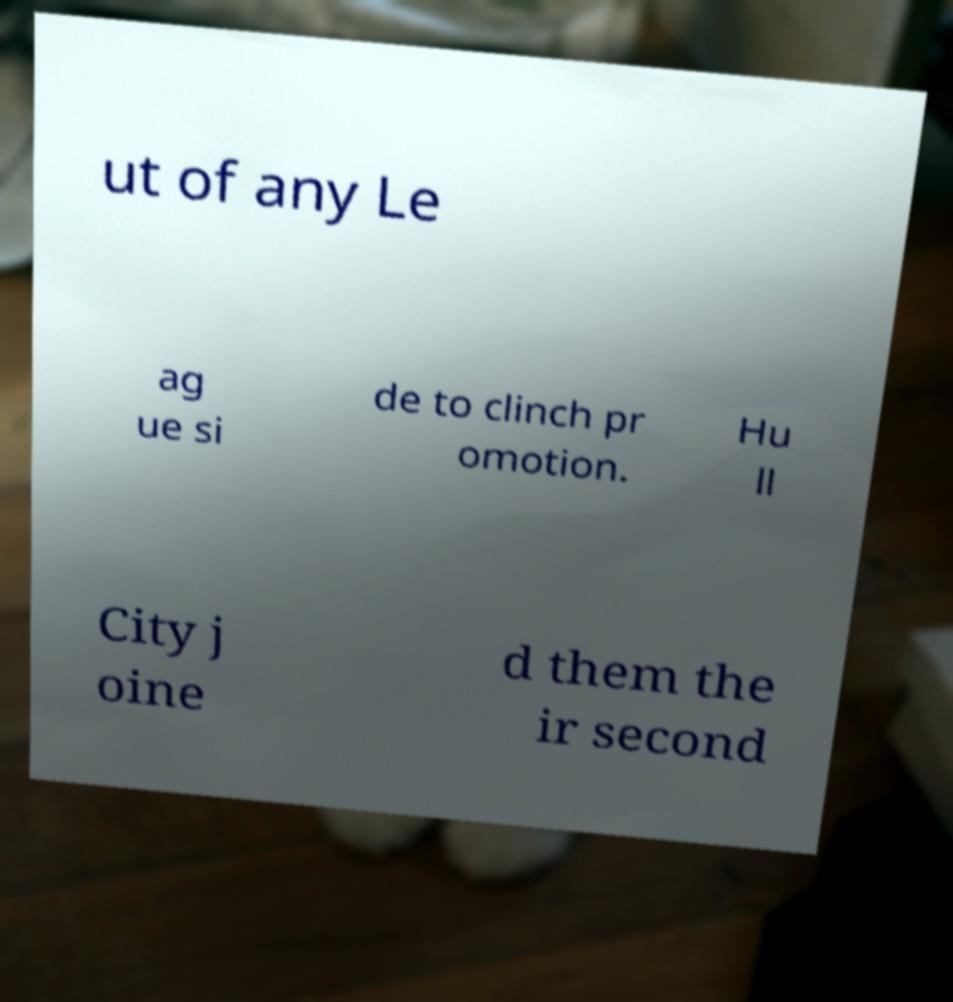Can you accurately transcribe the text from the provided image for me? ut of any Le ag ue si de to clinch pr omotion. Hu ll City j oine d them the ir second 